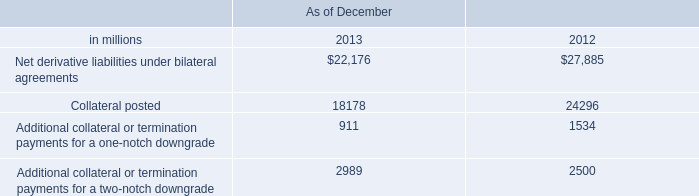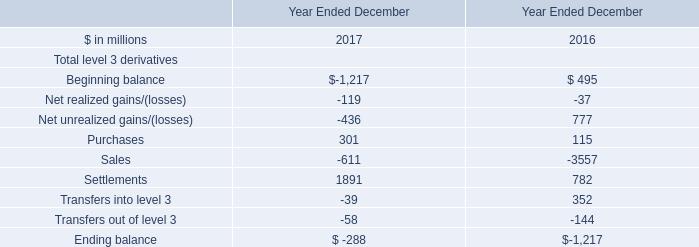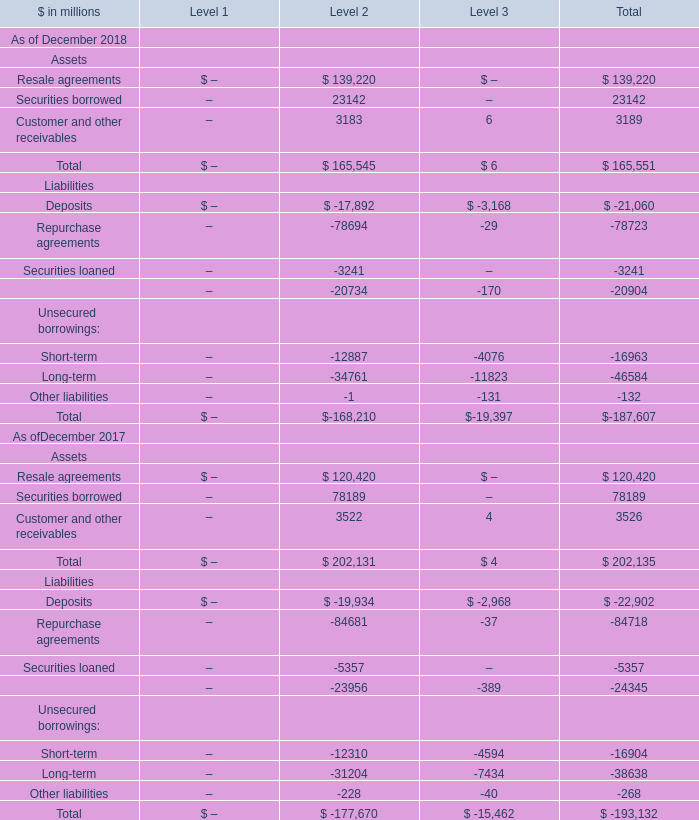In the Level with largest amount of Total Assets As of December 2018, what's the amount of Securities borrowed As of December 2018? (in million) 
Answer: 23142. 